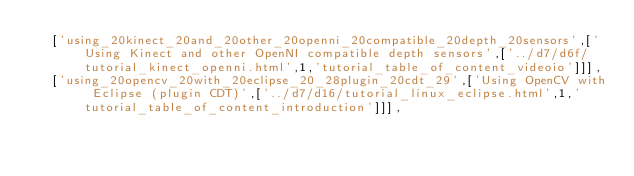Convert code to text. <code><loc_0><loc_0><loc_500><loc_500><_JavaScript_>  ['using_20kinect_20and_20other_20openni_20compatible_20depth_20sensors',['Using Kinect and other OpenNI compatible depth sensors',['../d7/d6f/tutorial_kinect_openni.html',1,'tutorial_table_of_content_videoio']]],
  ['using_20opencv_20with_20eclipse_20_28plugin_20cdt_29',['Using OpenCV with Eclipse (plugin CDT)',['../d7/d16/tutorial_linux_eclipse.html',1,'tutorial_table_of_content_introduction']]],</code> 